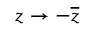Convert formula to latex. <formula><loc_0><loc_0><loc_500><loc_500>z \rightarrow - { \overline { z } }</formula> 